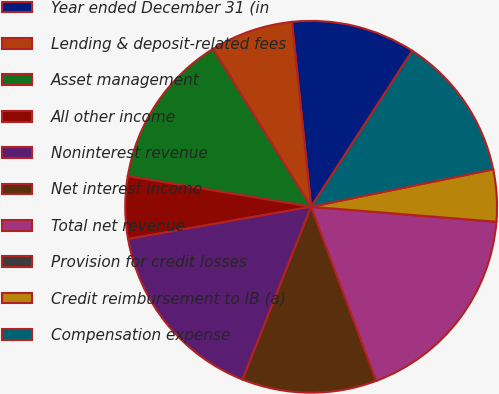<chart> <loc_0><loc_0><loc_500><loc_500><pie_chart><fcel>Year ended December 31 (in<fcel>Lending & deposit-related fees<fcel>Asset management<fcel>All other income<fcel>Noninterest revenue<fcel>Net interest income<fcel>Total net revenue<fcel>Provision for credit losses<fcel>Credit reimbursement to IB (a)<fcel>Compensation expense<nl><fcel>10.81%<fcel>7.21%<fcel>13.51%<fcel>5.41%<fcel>16.22%<fcel>11.71%<fcel>18.02%<fcel>0.0%<fcel>4.51%<fcel>12.61%<nl></chart> 